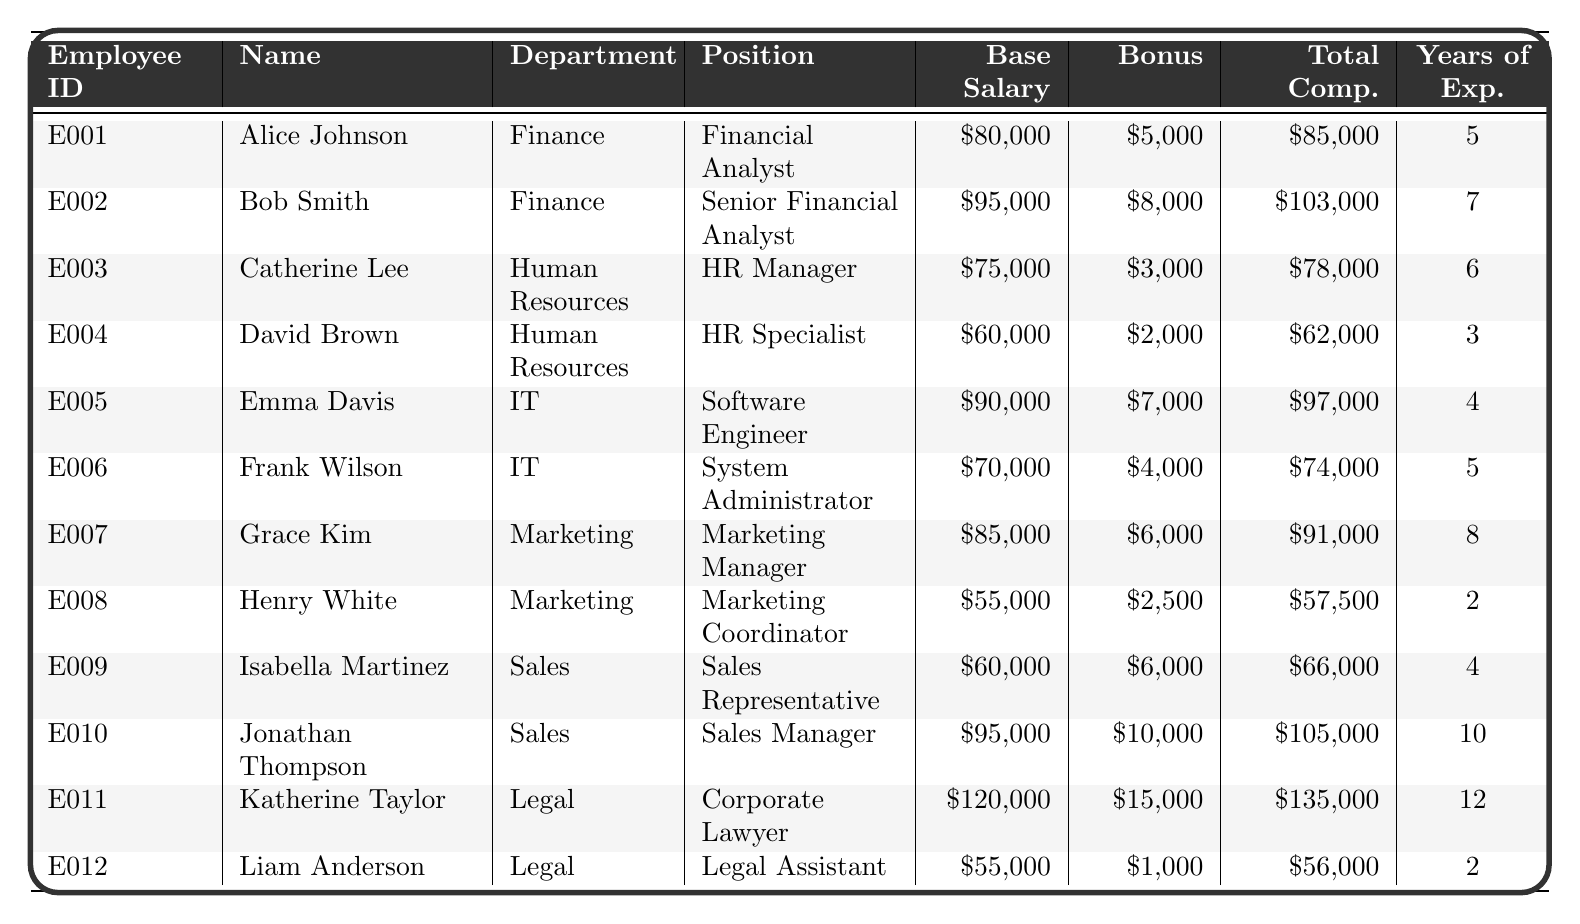What is the total compensation for Alice Johnson? According to the table, Alice Johnson has a total compensation of $85,000 listed under the 'Total Comp.' column.
Answer: $85,000 Which department has the highest average base salary? First, calculate the average base salary for each department: Finance ([$80,000 + $95,000]/2 = $87,500), Human Resources ([$75,000 + $60,000]/2 = $67,500), IT ([$90,000 + $70,000]/2 = $80,000), Marketing ([$85,000 + $55,000]/2 = $70,000), Sales ([$60,000 + $95,000]/2 = $77,500), and Legal ([$120,000 + $55,000]/2 = $87,500). Finance and Legal have the highest average base salary of $87,500.
Answer: Finance and Legal Is there a sales representative with a higher total compensation than $70,000? Yes, Jonathan Thompson, the Sales Manager has a total compensation of $105,000, which is greater than $70,000.
Answer: Yes What is the difference in total compensation between the highest and lowest paid employee? The highest total compensation is Katherine Taylor with $135,000 and the lowest is Henry White with $57,500. The difference is $135,000 - $57,500 = $77,500.
Answer: $77,500 How many employees in the IT department have more than 6 years of experience? There are two IT employees: Emma Davis (4 years) and Frank Wilson (5 years). Both have less than 6 years of experience, so the answer is 0.
Answer: 0 What is the average total compensation for all employees combined? First, sum all total compensations ($85,000 + $103,000 + $78,000 + $62,000 + $97,000 + $74,000 + $91,000 + $57,500 + $66,000 + $105,000 + $135,000 + $56,000) which equals $1,057,500, then divide by the number of employees (12). The average is $1,057,500 / 12 = $88,125.
Answer: $88,125 Is Emma Davis the highest paid employee in her department? To verify, look at the total compensations for IT: Emma Davis ($97,000) and Frank Wilson ($74,000). Since Emma's compensation is higher, the answer is yes.
Answer: Yes How many employees earn a bonus greater than $5,000? List the employees' bonuses: Alice Johnson ($5,000), Bob Smith ($8,000), Catherine Lee ($3,000), David Brown ($2,000), Emma Davis ($7,000), Frank Wilson ($4,000), Grace Kim ($6,000), Henry White ($2,500), Isabella Martinez ($6,000), Jonathan Thompson ($10,000), Katherine Taylor ($15,000), and Liam Anderson ($1,000). The employees earning more than $5,000 are Bob Smith, Emma Davis, Grace Kim, Jonathan Thompson, and Katherine Taylor, totaling to 5 employees.
Answer: 5 Which position in the Marketing department has the least total compensation? In the Marketing department, Grace Kim has a total compensation of $91,000 and Henry White has a total compensation of $57,500. Therefore, the position with the least total compensation is Marketing Coordinator (Henry White).
Answer: Marketing Coordinator What is the total base salary for all HR employees? Add the base salaries of HR employees: Catherine Lee ($75,000) and David Brown ($60,000), totaling $75,000 + $60,000 = $135,000.
Answer: $135,000 